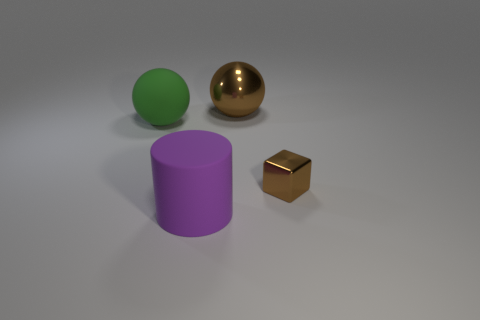Add 2 large gray balls. How many objects exist? 6 Subtract all brown balls. How many balls are left? 1 Subtract all large purple matte cylinders. Subtract all big brown shiny spheres. How many objects are left? 2 Add 2 tiny metal blocks. How many tiny metal blocks are left? 3 Add 3 big brown spheres. How many big brown spheres exist? 4 Subtract 0 blue balls. How many objects are left? 4 Subtract all blocks. How many objects are left? 3 Subtract all gray spheres. Subtract all green cubes. How many spheres are left? 2 